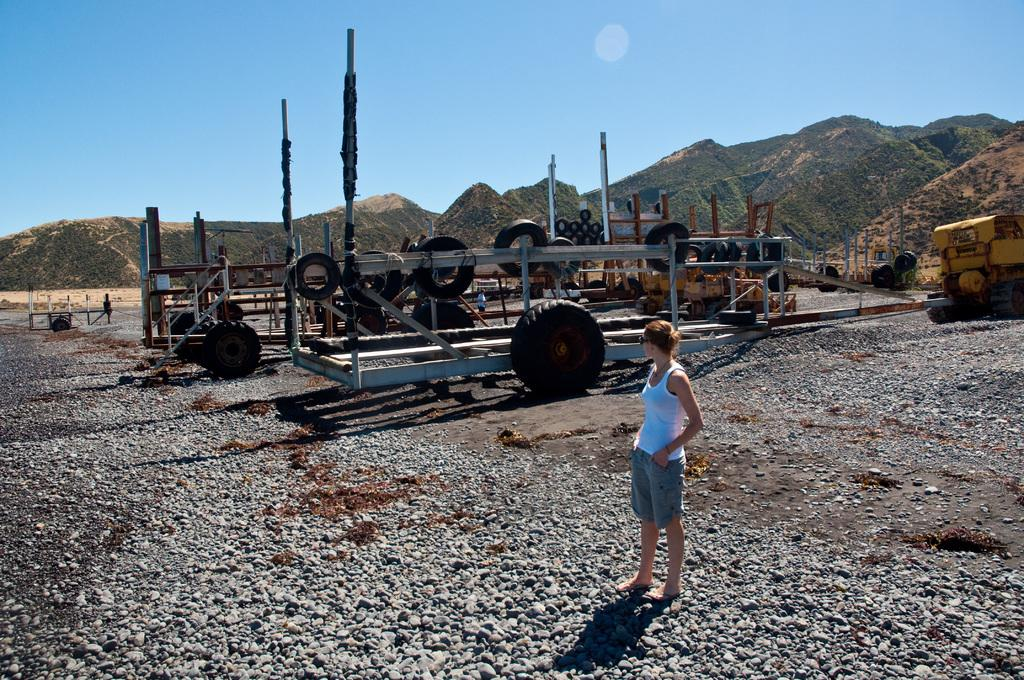What is the main subject of the image? There is a beautiful woman standing in the image. Can you describe what the woman is wearing? The woman is wearing a white top. In which direction is the woman looking? The woman is looking at a particular side. What else can be seen in the image besides the woman? There are vehicles and hills in the background of the image. What is visible at the top of the image? The sky is visible at the top of the image. How many prints can be seen on the woman's eye in the image? There are no prints visible on the woman's eye in the image. Can you describe how the woman is joining the vehicles in the image? The woman is not joining the vehicles in the image; she is simply standing and looking at a particular side. 